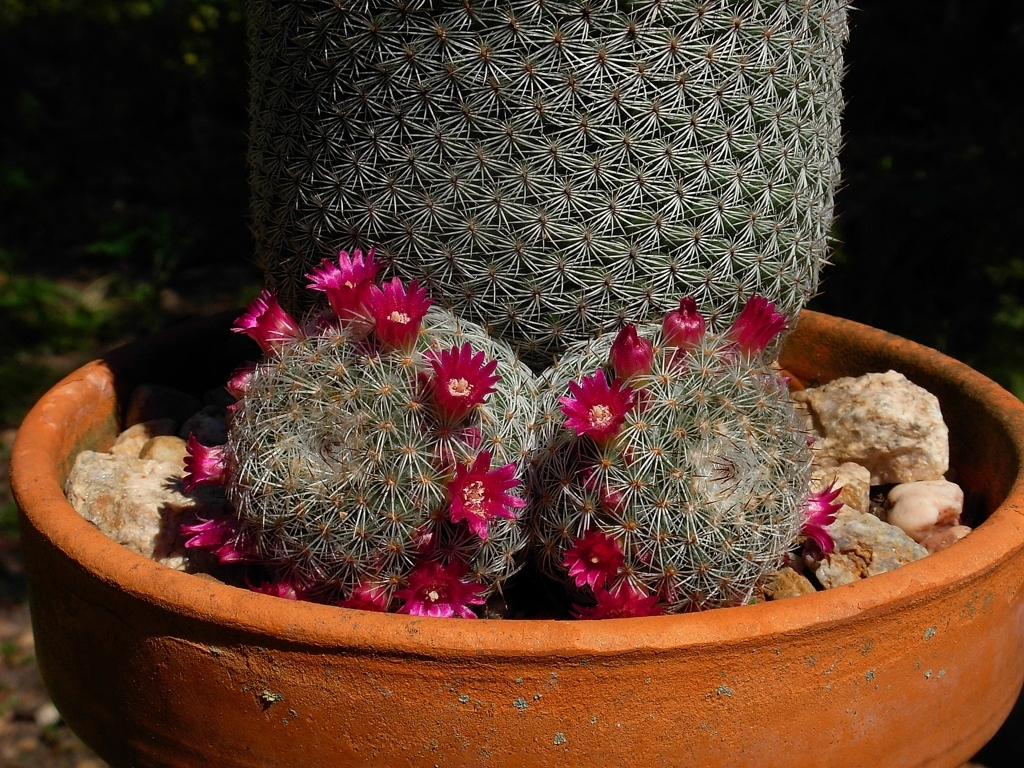How many flowers can be seen blooming on this cactus? There are several bright magenta flowers in full bloom, emerging from the cactus. If you count, you can see more than a dozen individual blooms, each adding a lively contrast to the muted tones of the cactus body. 